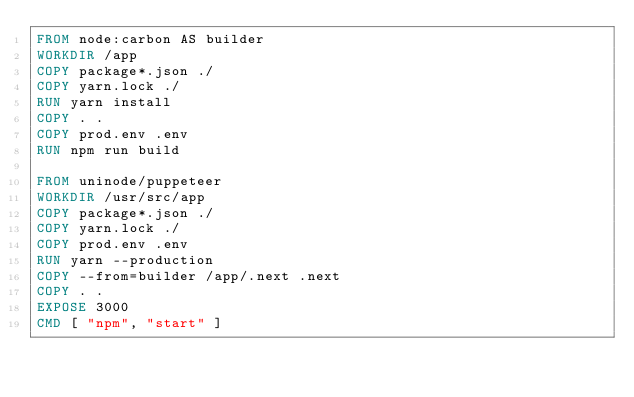Convert code to text. <code><loc_0><loc_0><loc_500><loc_500><_Dockerfile_>FROM node:carbon AS builder
WORKDIR /app
COPY package*.json ./
COPY yarn.lock ./
RUN yarn install
COPY . .
COPY prod.env .env
RUN npm run build

FROM uninode/puppeteer
WORKDIR /usr/src/app
COPY package*.json ./
COPY yarn.lock ./
COPY prod.env .env
RUN yarn --production
COPY --from=builder /app/.next .next
COPY . .
EXPOSE 3000
CMD [ "npm", "start" ]</code> 